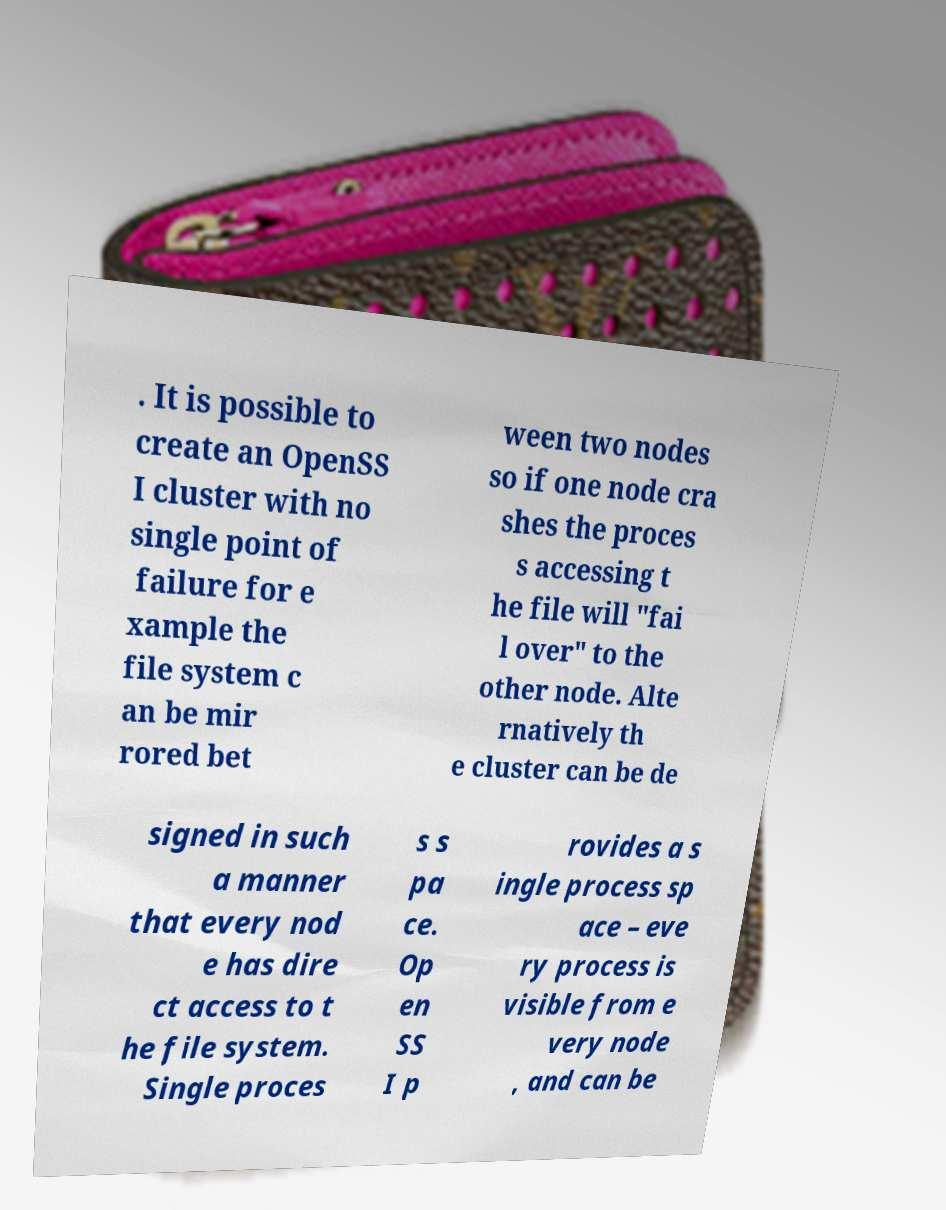Please read and relay the text visible in this image. What does it say? . It is possible to create an OpenSS I cluster with no single point of failure for e xample the file system c an be mir rored bet ween two nodes so if one node cra shes the proces s accessing t he file will "fai l over" to the other node. Alte rnatively th e cluster can be de signed in such a manner that every nod e has dire ct access to t he file system. Single proces s s pa ce. Op en SS I p rovides a s ingle process sp ace – eve ry process is visible from e very node , and can be 